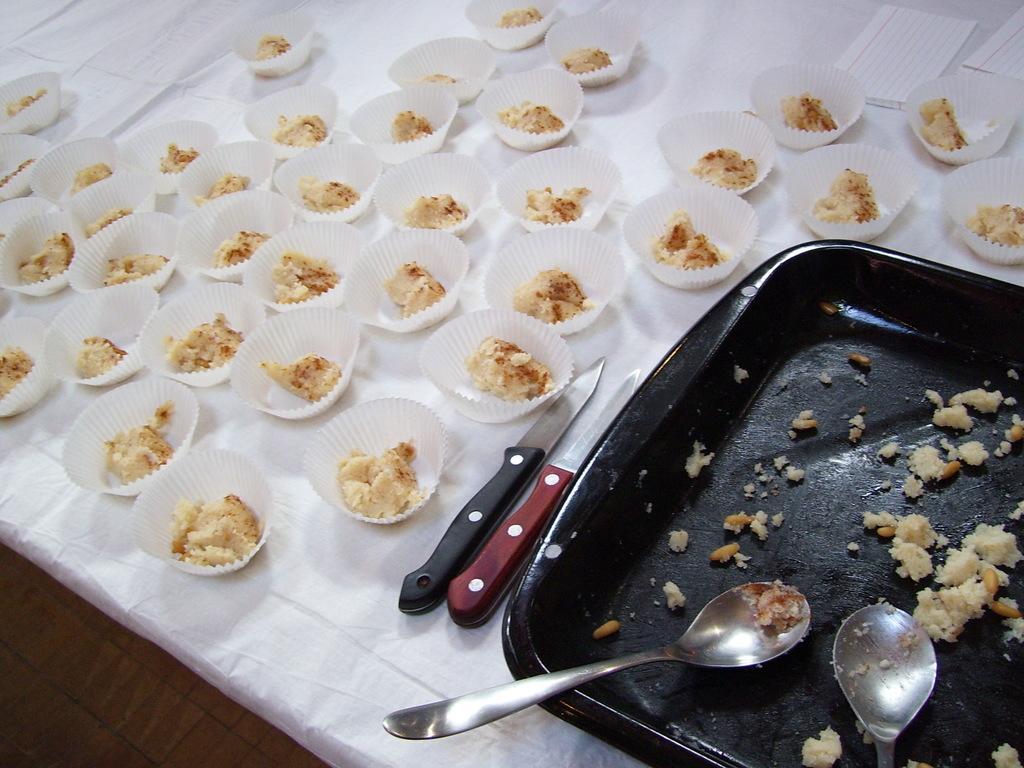Could you give a brief overview of what you see in this image? In this image we can see a tray with the spoons, the knives, tissue papers and a group of cups with some food in them which are placed on a table. 